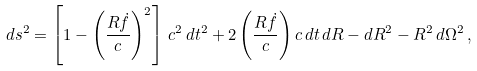<formula> <loc_0><loc_0><loc_500><loc_500>d s ^ { 2 } = \left [ 1 - \left ( \frac { R \dot { f } } { c } \right ) ^ { 2 } \right ] \, c ^ { 2 } \, d t ^ { 2 } + 2 \left ( \frac { R \dot { f } } { c } \right ) c \, d t \, d R - d R ^ { 2 } - R ^ { 2 } \, d \Omega ^ { 2 } \, ,</formula> 